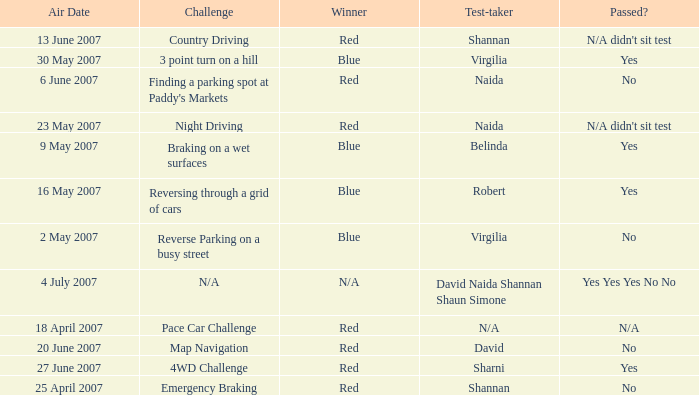What air date has a red winner and an emergency braking challenge? 25 April 2007. 